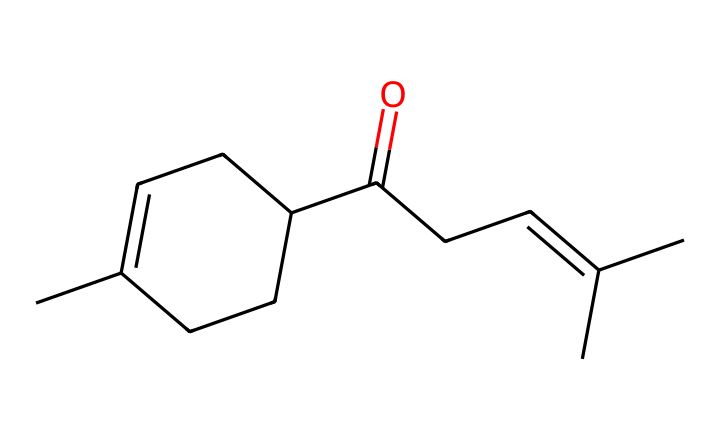How many carbon atoms are present in jasmone? By counting the "C" in the SMILES representation, we can identify the carbon atoms in the structure. For this compound, there are 15 carbon atoms represented.
Answer: 15 What is the functional group present in jasmone? The SMILES notation shows a carbonyl group (C=O) in the compound, which indicates it is a ketone.
Answer: ketone How many double bonds are there in the molecular structure of jasmone? Looking at the structure derived from the SMILES, there are two double bonds: one in the carbonyl and one in the carbon chain (CC=C).
Answer: 2 Which part of jasmone is responsible for its fragrant properties? The cyclic structure (C1=CC) often contributes to unique scents, as cyclic compounds generally provide complex fragrance profiles. In jasmone, the presence of the cyclohexene ring is notable.
Answer: cyclohexene ring Is jasmone soluble in water? Ketones typically have limited solubility in water due to their hydrophobic carbon chains and the bulkiness of the molecule.
Answer: limited solubility What type of isomerism can jasmone exhibit? The structure includes a double bond, allowing for cis-trans (geometric) isomerism concerning the non-rotatable C=C bond in the chain.
Answer: cis-trans isomerism 